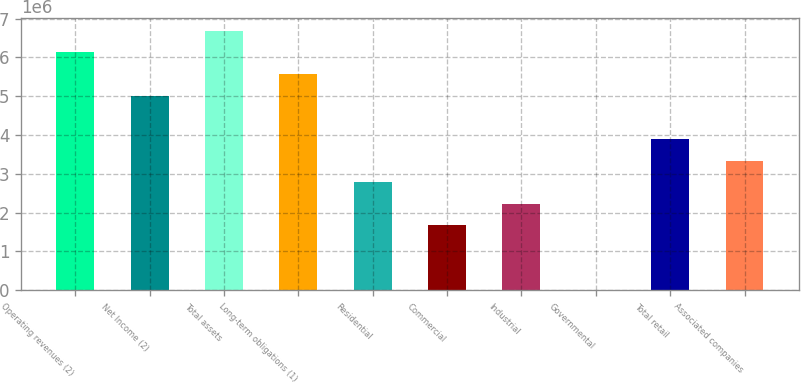Convert chart to OTSL. <chart><loc_0><loc_0><loc_500><loc_500><bar_chart><fcel>Operating revenues (2)<fcel>Net Income (2)<fcel>Total assets<fcel>Long-term obligations (1)<fcel>Residential<fcel>Commercial<fcel>Industrial<fcel>Governmental<fcel>Total retail<fcel>Associated companies<nl><fcel>6.12599e+06<fcel>5.01218e+06<fcel>6.6829e+06<fcel>5.56908e+06<fcel>2.78455e+06<fcel>1.67074e+06<fcel>2.22764e+06<fcel>18<fcel>3.89836e+06<fcel>3.34146e+06<nl></chart> 